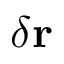<formula> <loc_0><loc_0><loc_500><loc_500>\delta r</formula> 